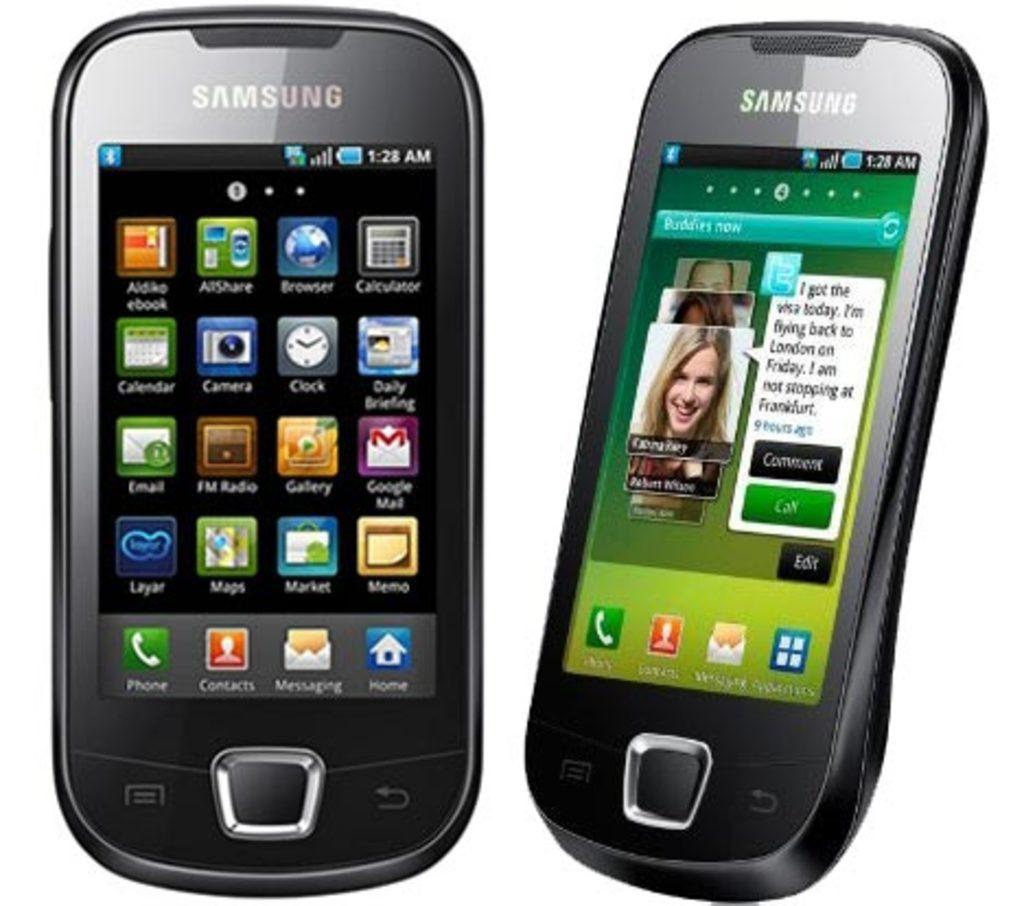<image>
Share a concise interpretation of the image provided. Two Samsung brand phones are next to each other. 